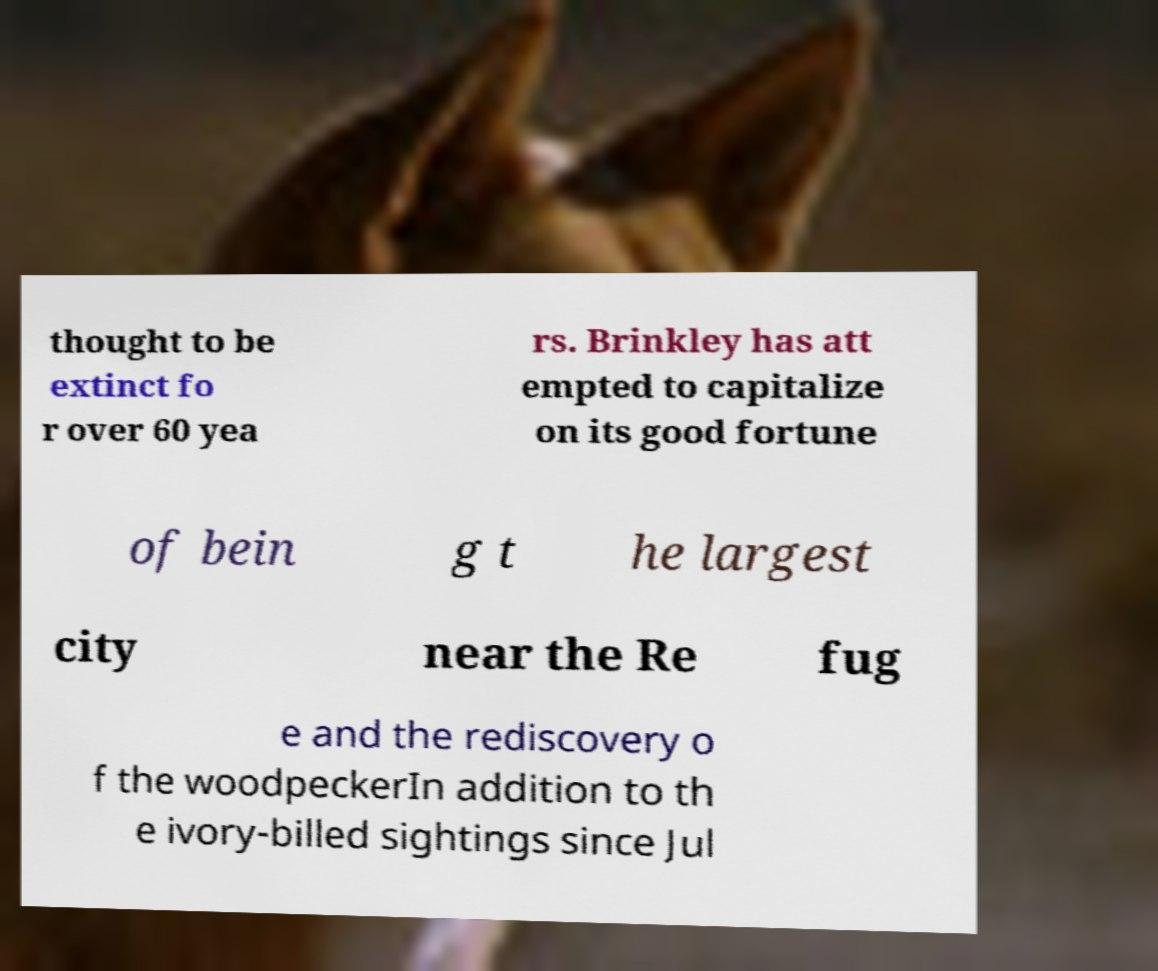There's text embedded in this image that I need extracted. Can you transcribe it verbatim? thought to be extinct fo r over 60 yea rs. Brinkley has att empted to capitalize on its good fortune of bein g t he largest city near the Re fug e and the rediscovery o f the woodpeckerIn addition to th e ivory-billed sightings since Jul 